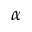<formula> <loc_0><loc_0><loc_500><loc_500>\alpha</formula> 